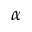<formula> <loc_0><loc_0><loc_500><loc_500>\alpha</formula> 